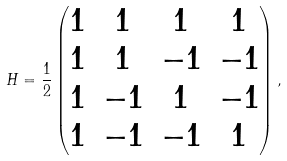<formula> <loc_0><loc_0><loc_500><loc_500>H = \frac { 1 } { 2 } \begin{pmatrix} 1 & 1 & 1 & 1 \\ 1 & 1 & - 1 & - 1 \\ 1 & - 1 & 1 & - 1 \\ 1 & - 1 & - 1 & 1 \end{pmatrix} ,</formula> 